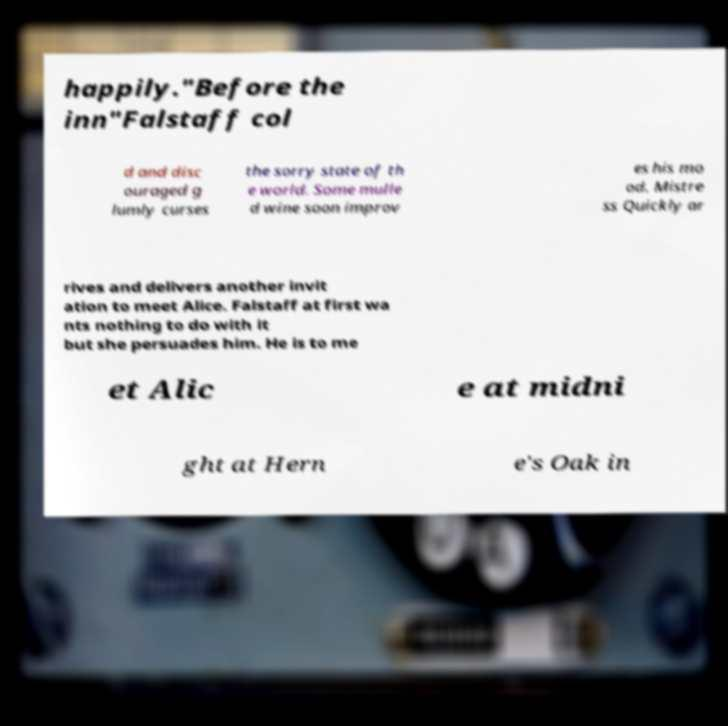There's text embedded in this image that I need extracted. Can you transcribe it verbatim? happily."Before the inn"Falstaff col d and disc ouraged g lumly curses the sorry state of th e world. Some mulle d wine soon improv es his mo od. Mistre ss Quickly ar rives and delivers another invit ation to meet Alice. Falstaff at first wa nts nothing to do with it but she persuades him. He is to me et Alic e at midni ght at Hern e's Oak in 